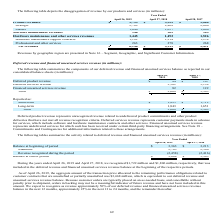According to Netapp's financial document, How much was included in the deferred revenue and financed unearned services revenue balance at the beginning of 2019? According to the financial document, 1,722 (in millions). The relevant text states: "April 26, 2019 and April 27, 2018, we recognized $1,722 million and $1,806 million, respectively, that was included in the deferred revenue and financed un..." Also, What were the additions in 2019? According to the financial document, 2,763 (in millions). The relevant text states: "Additions 2,763 2,566..." Also, What was the balance at the end of period in 2018? According to the financial document, 3,363 (in millions). The relevant text states: "Balance at beginning of period $ 3,363 $ 3,213..." Also, can you calculate: What was the change in the balance at beginning of period between 2018 and 2019? Based on the calculation: 3,363-3,213, the result is 150 (in millions). This is based on the information: "Balance at beginning of period $ 3,363 $ 3,213 Balance at beginning of period $ 3,363 $ 3,213..." The key data points involved are: 3,213, 3,363. Also, How many years did balance at end of period exceed $3,500 million? Based on the analysis, there are 1 instances. The counting process: 2019. Also, can you calculate: What was the percentage change in additions between 2018 and 2019? To answer this question, I need to perform calculations using the financial data. The calculation is: (2,763-2,566)/2,566, which equals 7.68 (percentage). This is based on the information: "Additions 2,763 2,566 Additions 2,763 2,566..." The key data points involved are: 2,566, 2,763. 